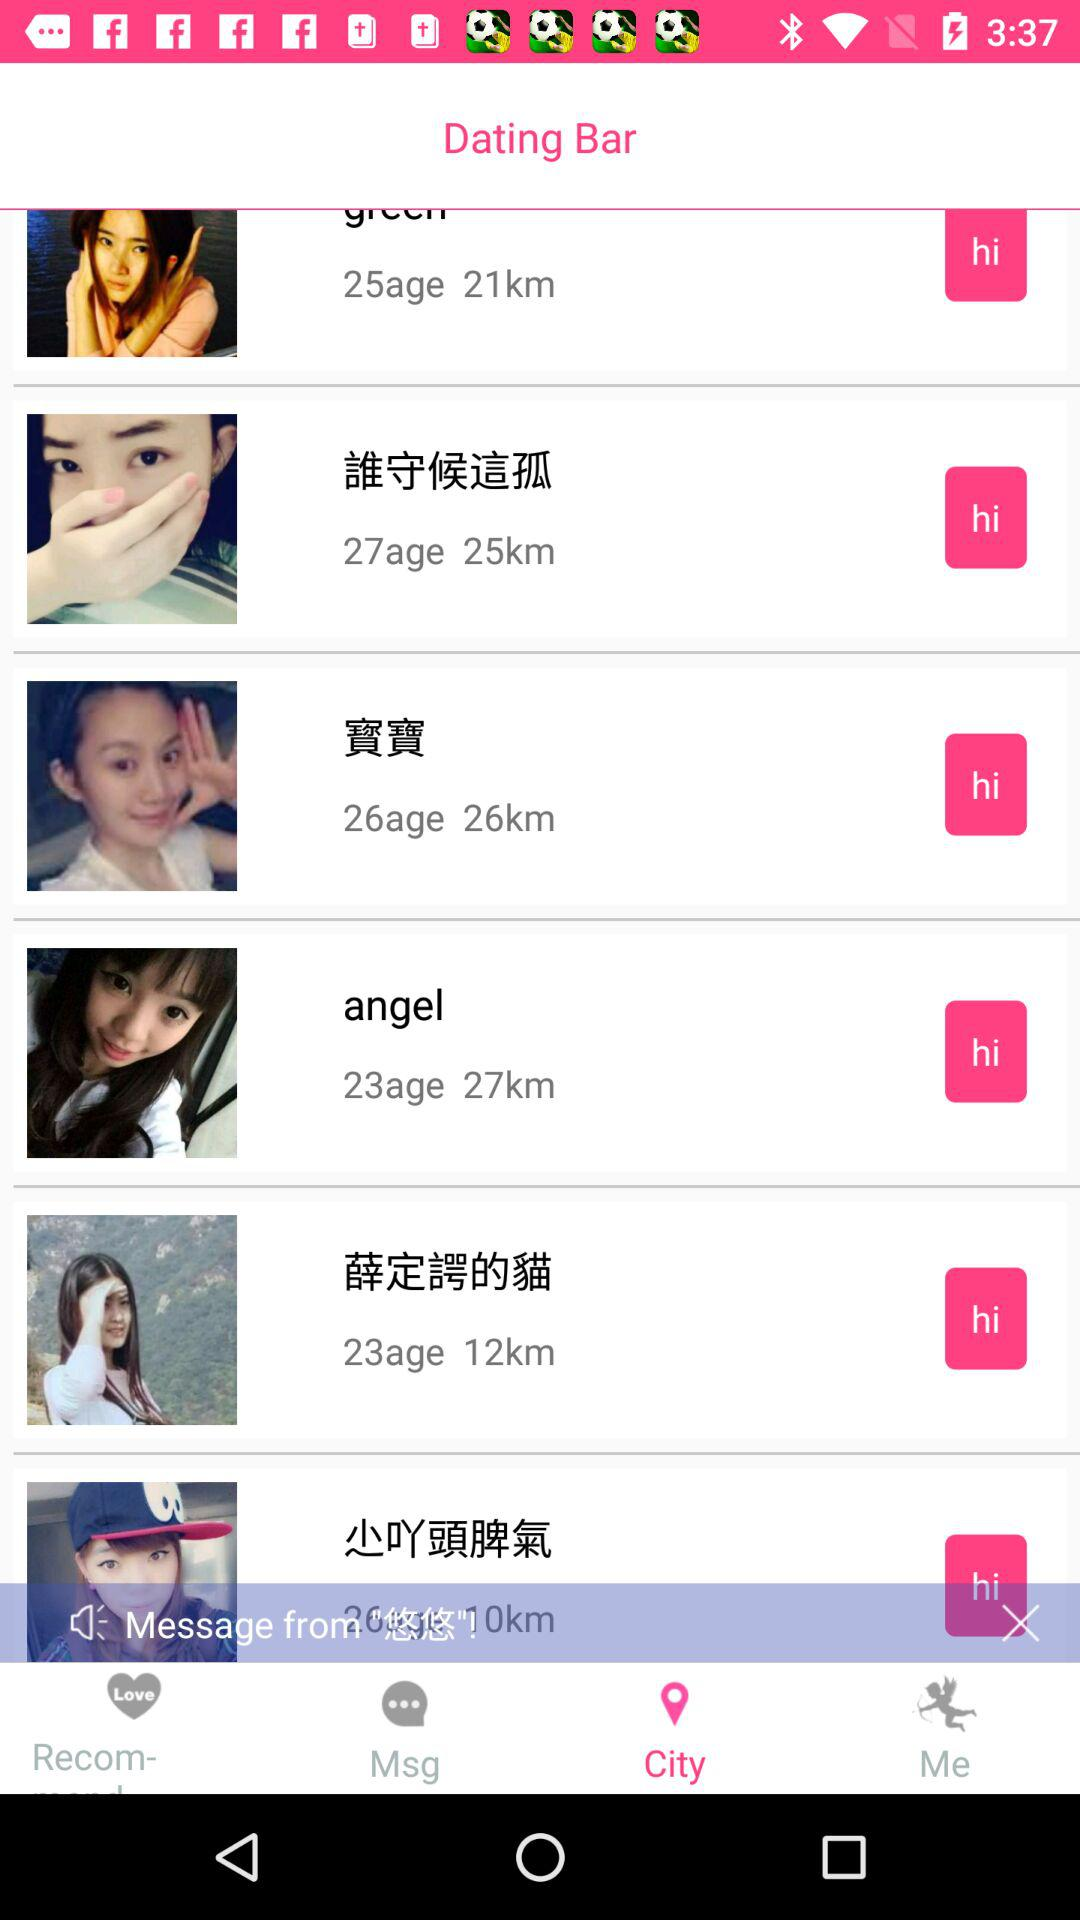How far is "angel"? "angel" is 27 km away. 